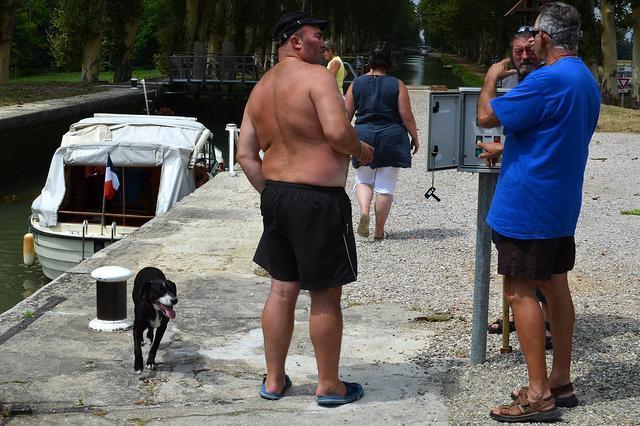How many people are visible?
Give a very brief answer. 3. 